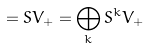<formula> <loc_0><loc_0><loc_500><loc_500>= S V _ { + } = \bigoplus _ { k } S ^ { k } V _ { + }</formula> 